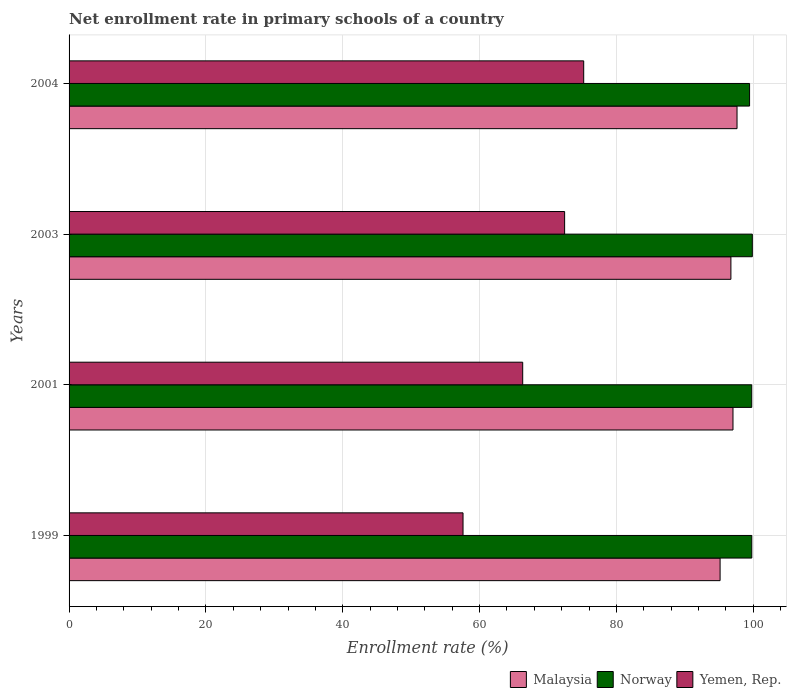How many different coloured bars are there?
Ensure brevity in your answer.  3. Are the number of bars per tick equal to the number of legend labels?
Your answer should be compact. Yes. Are the number of bars on each tick of the Y-axis equal?
Your answer should be very brief. Yes. How many bars are there on the 1st tick from the bottom?
Keep it short and to the point. 3. What is the enrollment rate in primary schools in Yemen, Rep. in 2001?
Your answer should be very brief. 66.3. Across all years, what is the maximum enrollment rate in primary schools in Malaysia?
Offer a very short reply. 97.62. Across all years, what is the minimum enrollment rate in primary schools in Yemen, Rep.?
Keep it short and to the point. 57.58. In which year was the enrollment rate in primary schools in Malaysia maximum?
Make the answer very short. 2004. In which year was the enrollment rate in primary schools in Yemen, Rep. minimum?
Offer a very short reply. 1999. What is the total enrollment rate in primary schools in Norway in the graph?
Offer a terse response. 398.86. What is the difference between the enrollment rate in primary schools in Malaysia in 2001 and that in 2004?
Make the answer very short. -0.59. What is the difference between the enrollment rate in primary schools in Norway in 2001 and the enrollment rate in primary schools in Yemen, Rep. in 1999?
Your answer should be compact. 42.19. What is the average enrollment rate in primary schools in Norway per year?
Keep it short and to the point. 99.71. In the year 2004, what is the difference between the enrollment rate in primary schools in Malaysia and enrollment rate in primary schools in Yemen, Rep.?
Your response must be concise. 22.41. What is the ratio of the enrollment rate in primary schools in Norway in 2003 to that in 2004?
Your answer should be compact. 1. Is the enrollment rate in primary schools in Norway in 2001 less than that in 2003?
Offer a very short reply. Yes. Is the difference between the enrollment rate in primary schools in Malaysia in 1999 and 2003 greater than the difference between the enrollment rate in primary schools in Yemen, Rep. in 1999 and 2003?
Give a very brief answer. Yes. What is the difference between the highest and the second highest enrollment rate in primary schools in Malaysia?
Your answer should be compact. 0.59. What is the difference between the highest and the lowest enrollment rate in primary schools in Yemen, Rep.?
Provide a succinct answer. 17.64. In how many years, is the enrollment rate in primary schools in Yemen, Rep. greater than the average enrollment rate in primary schools in Yemen, Rep. taken over all years?
Give a very brief answer. 2. Is the sum of the enrollment rate in primary schools in Malaysia in 2003 and 2004 greater than the maximum enrollment rate in primary schools in Yemen, Rep. across all years?
Make the answer very short. Yes. What does the 1st bar from the top in 2003 represents?
Your answer should be compact. Yemen, Rep. What does the 1st bar from the bottom in 2001 represents?
Your answer should be compact. Malaysia. Does the graph contain any zero values?
Keep it short and to the point. No. Where does the legend appear in the graph?
Your response must be concise. Bottom right. What is the title of the graph?
Offer a terse response. Net enrollment rate in primary schools of a country. Does "Europe(all income levels)" appear as one of the legend labels in the graph?
Offer a terse response. No. What is the label or title of the X-axis?
Keep it short and to the point. Enrollment rate (%). What is the Enrollment rate (%) of Malaysia in 1999?
Your answer should be compact. 95.14. What is the Enrollment rate (%) of Norway in 1999?
Ensure brevity in your answer.  99.78. What is the Enrollment rate (%) of Yemen, Rep. in 1999?
Your response must be concise. 57.58. What is the Enrollment rate (%) of Malaysia in 2001?
Provide a short and direct response. 97.03. What is the Enrollment rate (%) of Norway in 2001?
Provide a succinct answer. 99.77. What is the Enrollment rate (%) in Yemen, Rep. in 2001?
Your answer should be compact. 66.3. What is the Enrollment rate (%) in Malaysia in 2003?
Make the answer very short. 96.73. What is the Enrollment rate (%) of Norway in 2003?
Ensure brevity in your answer.  99.86. What is the Enrollment rate (%) of Yemen, Rep. in 2003?
Keep it short and to the point. 72.42. What is the Enrollment rate (%) in Malaysia in 2004?
Offer a terse response. 97.62. What is the Enrollment rate (%) of Norway in 2004?
Provide a short and direct response. 99.45. What is the Enrollment rate (%) of Yemen, Rep. in 2004?
Ensure brevity in your answer.  75.21. Across all years, what is the maximum Enrollment rate (%) in Malaysia?
Provide a short and direct response. 97.62. Across all years, what is the maximum Enrollment rate (%) of Norway?
Keep it short and to the point. 99.86. Across all years, what is the maximum Enrollment rate (%) of Yemen, Rep.?
Give a very brief answer. 75.21. Across all years, what is the minimum Enrollment rate (%) of Malaysia?
Your answer should be very brief. 95.14. Across all years, what is the minimum Enrollment rate (%) of Norway?
Offer a very short reply. 99.45. Across all years, what is the minimum Enrollment rate (%) of Yemen, Rep.?
Your response must be concise. 57.58. What is the total Enrollment rate (%) of Malaysia in the graph?
Provide a short and direct response. 386.52. What is the total Enrollment rate (%) in Norway in the graph?
Your answer should be compact. 398.86. What is the total Enrollment rate (%) in Yemen, Rep. in the graph?
Provide a succinct answer. 271.51. What is the difference between the Enrollment rate (%) in Malaysia in 1999 and that in 2001?
Offer a very short reply. -1.88. What is the difference between the Enrollment rate (%) of Norway in 1999 and that in 2001?
Provide a succinct answer. 0.01. What is the difference between the Enrollment rate (%) of Yemen, Rep. in 1999 and that in 2001?
Keep it short and to the point. -8.72. What is the difference between the Enrollment rate (%) in Malaysia in 1999 and that in 2003?
Your response must be concise. -1.58. What is the difference between the Enrollment rate (%) in Norway in 1999 and that in 2003?
Give a very brief answer. -0.08. What is the difference between the Enrollment rate (%) of Yemen, Rep. in 1999 and that in 2003?
Make the answer very short. -14.85. What is the difference between the Enrollment rate (%) in Malaysia in 1999 and that in 2004?
Keep it short and to the point. -2.47. What is the difference between the Enrollment rate (%) of Norway in 1999 and that in 2004?
Offer a very short reply. 0.32. What is the difference between the Enrollment rate (%) in Yemen, Rep. in 1999 and that in 2004?
Offer a terse response. -17.64. What is the difference between the Enrollment rate (%) in Malaysia in 2001 and that in 2003?
Provide a short and direct response. 0.3. What is the difference between the Enrollment rate (%) of Norway in 2001 and that in 2003?
Give a very brief answer. -0.09. What is the difference between the Enrollment rate (%) in Yemen, Rep. in 2001 and that in 2003?
Ensure brevity in your answer.  -6.13. What is the difference between the Enrollment rate (%) of Malaysia in 2001 and that in 2004?
Your answer should be compact. -0.59. What is the difference between the Enrollment rate (%) in Norway in 2001 and that in 2004?
Your response must be concise. 0.32. What is the difference between the Enrollment rate (%) in Yemen, Rep. in 2001 and that in 2004?
Provide a short and direct response. -8.91. What is the difference between the Enrollment rate (%) of Malaysia in 2003 and that in 2004?
Your response must be concise. -0.89. What is the difference between the Enrollment rate (%) of Norway in 2003 and that in 2004?
Provide a succinct answer. 0.4. What is the difference between the Enrollment rate (%) of Yemen, Rep. in 2003 and that in 2004?
Your answer should be compact. -2.79. What is the difference between the Enrollment rate (%) in Malaysia in 1999 and the Enrollment rate (%) in Norway in 2001?
Provide a short and direct response. -4.63. What is the difference between the Enrollment rate (%) of Malaysia in 1999 and the Enrollment rate (%) of Yemen, Rep. in 2001?
Your answer should be compact. 28.85. What is the difference between the Enrollment rate (%) of Norway in 1999 and the Enrollment rate (%) of Yemen, Rep. in 2001?
Provide a short and direct response. 33.48. What is the difference between the Enrollment rate (%) in Malaysia in 1999 and the Enrollment rate (%) in Norway in 2003?
Offer a very short reply. -4.71. What is the difference between the Enrollment rate (%) in Malaysia in 1999 and the Enrollment rate (%) in Yemen, Rep. in 2003?
Provide a succinct answer. 22.72. What is the difference between the Enrollment rate (%) in Norway in 1999 and the Enrollment rate (%) in Yemen, Rep. in 2003?
Give a very brief answer. 27.35. What is the difference between the Enrollment rate (%) of Malaysia in 1999 and the Enrollment rate (%) of Norway in 2004?
Provide a short and direct response. -4.31. What is the difference between the Enrollment rate (%) in Malaysia in 1999 and the Enrollment rate (%) in Yemen, Rep. in 2004?
Ensure brevity in your answer.  19.93. What is the difference between the Enrollment rate (%) in Norway in 1999 and the Enrollment rate (%) in Yemen, Rep. in 2004?
Your response must be concise. 24.57. What is the difference between the Enrollment rate (%) of Malaysia in 2001 and the Enrollment rate (%) of Norway in 2003?
Offer a terse response. -2.83. What is the difference between the Enrollment rate (%) in Malaysia in 2001 and the Enrollment rate (%) in Yemen, Rep. in 2003?
Your response must be concise. 24.6. What is the difference between the Enrollment rate (%) of Norway in 2001 and the Enrollment rate (%) of Yemen, Rep. in 2003?
Your response must be concise. 27.35. What is the difference between the Enrollment rate (%) of Malaysia in 2001 and the Enrollment rate (%) of Norway in 2004?
Your response must be concise. -2.43. What is the difference between the Enrollment rate (%) of Malaysia in 2001 and the Enrollment rate (%) of Yemen, Rep. in 2004?
Your response must be concise. 21.82. What is the difference between the Enrollment rate (%) of Norway in 2001 and the Enrollment rate (%) of Yemen, Rep. in 2004?
Give a very brief answer. 24.56. What is the difference between the Enrollment rate (%) in Malaysia in 2003 and the Enrollment rate (%) in Norway in 2004?
Provide a succinct answer. -2.73. What is the difference between the Enrollment rate (%) of Malaysia in 2003 and the Enrollment rate (%) of Yemen, Rep. in 2004?
Give a very brief answer. 21.51. What is the difference between the Enrollment rate (%) in Norway in 2003 and the Enrollment rate (%) in Yemen, Rep. in 2004?
Offer a very short reply. 24.64. What is the average Enrollment rate (%) of Malaysia per year?
Offer a terse response. 96.63. What is the average Enrollment rate (%) of Norway per year?
Your answer should be compact. 99.71. What is the average Enrollment rate (%) of Yemen, Rep. per year?
Make the answer very short. 67.88. In the year 1999, what is the difference between the Enrollment rate (%) in Malaysia and Enrollment rate (%) in Norway?
Ensure brevity in your answer.  -4.63. In the year 1999, what is the difference between the Enrollment rate (%) of Malaysia and Enrollment rate (%) of Yemen, Rep.?
Your answer should be compact. 37.57. In the year 1999, what is the difference between the Enrollment rate (%) in Norway and Enrollment rate (%) in Yemen, Rep.?
Your response must be concise. 42.2. In the year 2001, what is the difference between the Enrollment rate (%) in Malaysia and Enrollment rate (%) in Norway?
Provide a short and direct response. -2.74. In the year 2001, what is the difference between the Enrollment rate (%) of Malaysia and Enrollment rate (%) of Yemen, Rep.?
Offer a very short reply. 30.73. In the year 2001, what is the difference between the Enrollment rate (%) in Norway and Enrollment rate (%) in Yemen, Rep.?
Keep it short and to the point. 33.47. In the year 2003, what is the difference between the Enrollment rate (%) in Malaysia and Enrollment rate (%) in Norway?
Your answer should be compact. -3.13. In the year 2003, what is the difference between the Enrollment rate (%) of Malaysia and Enrollment rate (%) of Yemen, Rep.?
Offer a very short reply. 24.3. In the year 2003, what is the difference between the Enrollment rate (%) of Norway and Enrollment rate (%) of Yemen, Rep.?
Provide a succinct answer. 27.43. In the year 2004, what is the difference between the Enrollment rate (%) of Malaysia and Enrollment rate (%) of Norway?
Offer a terse response. -1.84. In the year 2004, what is the difference between the Enrollment rate (%) in Malaysia and Enrollment rate (%) in Yemen, Rep.?
Ensure brevity in your answer.  22.41. In the year 2004, what is the difference between the Enrollment rate (%) in Norway and Enrollment rate (%) in Yemen, Rep.?
Provide a succinct answer. 24.24. What is the ratio of the Enrollment rate (%) in Malaysia in 1999 to that in 2001?
Offer a very short reply. 0.98. What is the ratio of the Enrollment rate (%) of Yemen, Rep. in 1999 to that in 2001?
Offer a terse response. 0.87. What is the ratio of the Enrollment rate (%) of Malaysia in 1999 to that in 2003?
Your answer should be very brief. 0.98. What is the ratio of the Enrollment rate (%) in Norway in 1999 to that in 2003?
Your answer should be very brief. 1. What is the ratio of the Enrollment rate (%) in Yemen, Rep. in 1999 to that in 2003?
Your answer should be compact. 0.8. What is the ratio of the Enrollment rate (%) of Malaysia in 1999 to that in 2004?
Ensure brevity in your answer.  0.97. What is the ratio of the Enrollment rate (%) of Yemen, Rep. in 1999 to that in 2004?
Make the answer very short. 0.77. What is the ratio of the Enrollment rate (%) in Norway in 2001 to that in 2003?
Offer a terse response. 1. What is the ratio of the Enrollment rate (%) of Yemen, Rep. in 2001 to that in 2003?
Offer a very short reply. 0.92. What is the ratio of the Enrollment rate (%) of Norway in 2001 to that in 2004?
Provide a succinct answer. 1. What is the ratio of the Enrollment rate (%) in Yemen, Rep. in 2001 to that in 2004?
Keep it short and to the point. 0.88. What is the ratio of the Enrollment rate (%) in Yemen, Rep. in 2003 to that in 2004?
Your answer should be compact. 0.96. What is the difference between the highest and the second highest Enrollment rate (%) of Malaysia?
Offer a terse response. 0.59. What is the difference between the highest and the second highest Enrollment rate (%) in Norway?
Keep it short and to the point. 0.08. What is the difference between the highest and the second highest Enrollment rate (%) in Yemen, Rep.?
Give a very brief answer. 2.79. What is the difference between the highest and the lowest Enrollment rate (%) in Malaysia?
Make the answer very short. 2.47. What is the difference between the highest and the lowest Enrollment rate (%) of Norway?
Offer a terse response. 0.4. What is the difference between the highest and the lowest Enrollment rate (%) of Yemen, Rep.?
Give a very brief answer. 17.64. 